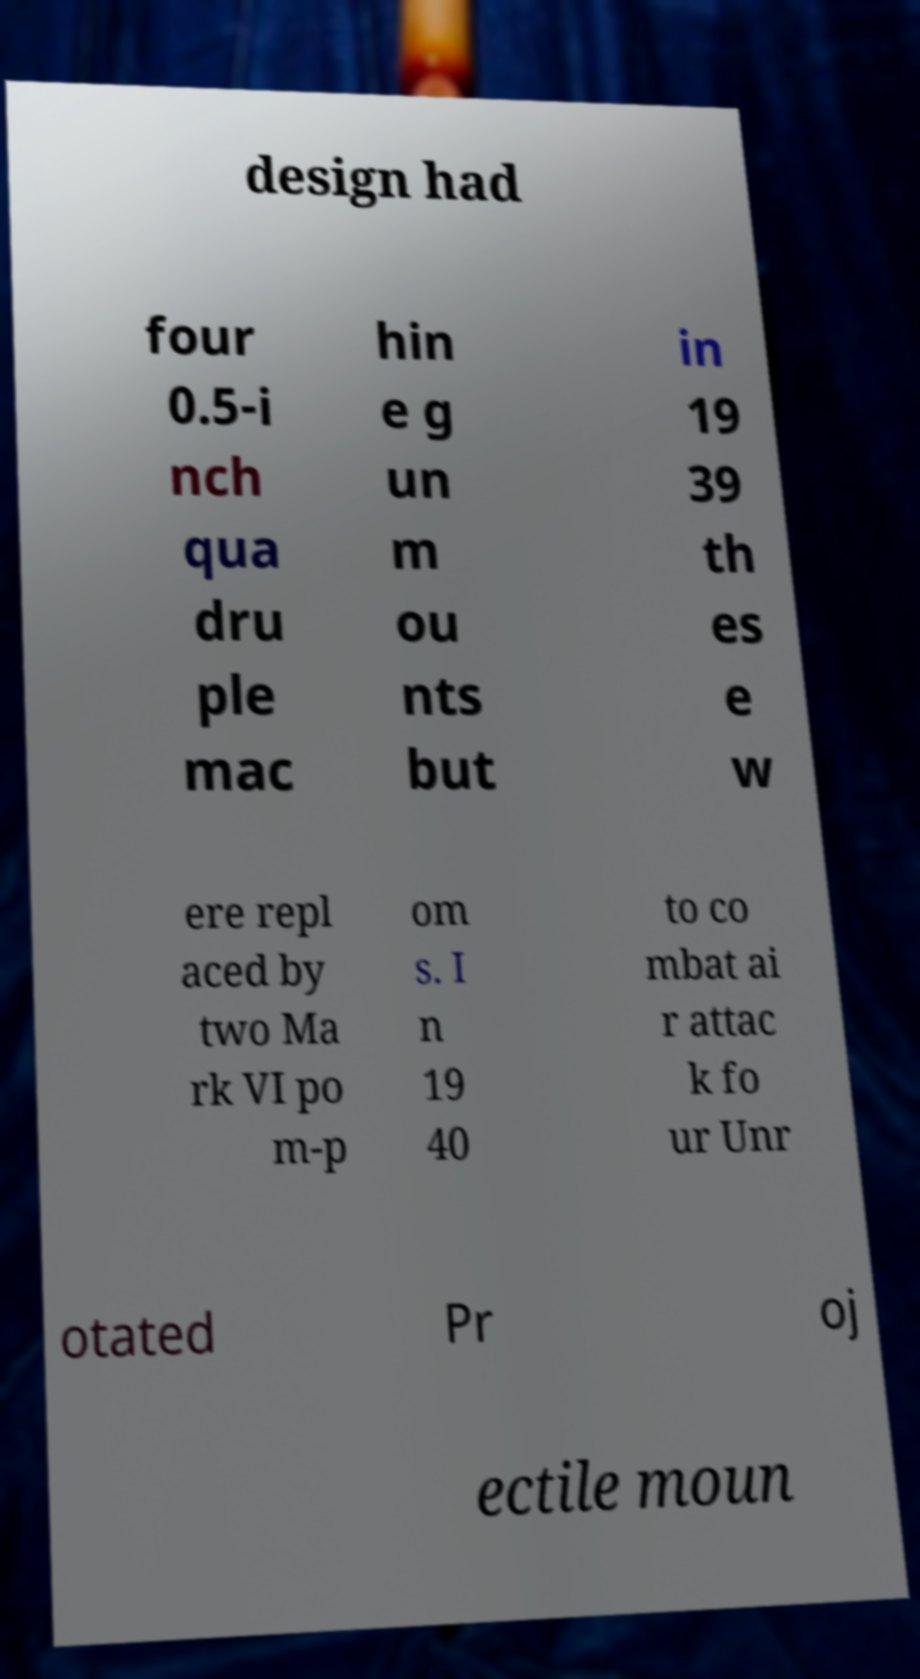There's text embedded in this image that I need extracted. Can you transcribe it verbatim? design had four 0.5-i nch qua dru ple mac hin e g un m ou nts but in 19 39 th es e w ere repl aced by two Ma rk VI po m-p om s. I n 19 40 to co mbat ai r attac k fo ur Unr otated Pr oj ectile moun 